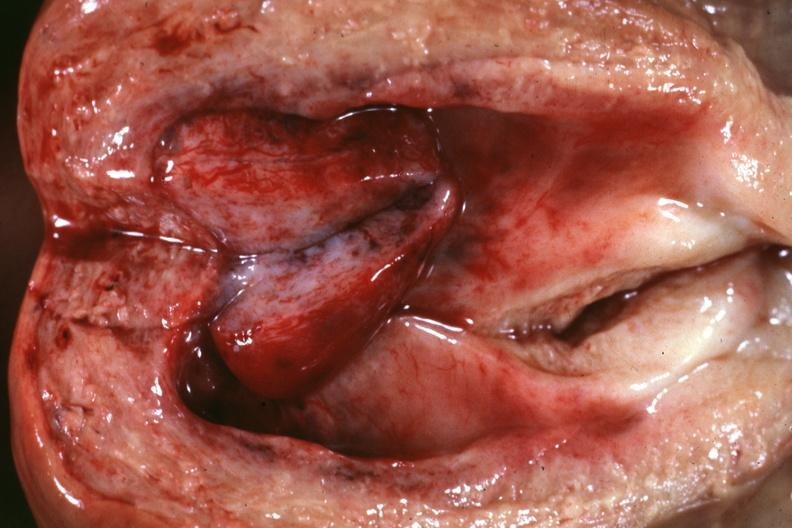where does this part belong to?
Answer the question using a single word or phrase. Female reproductive system 